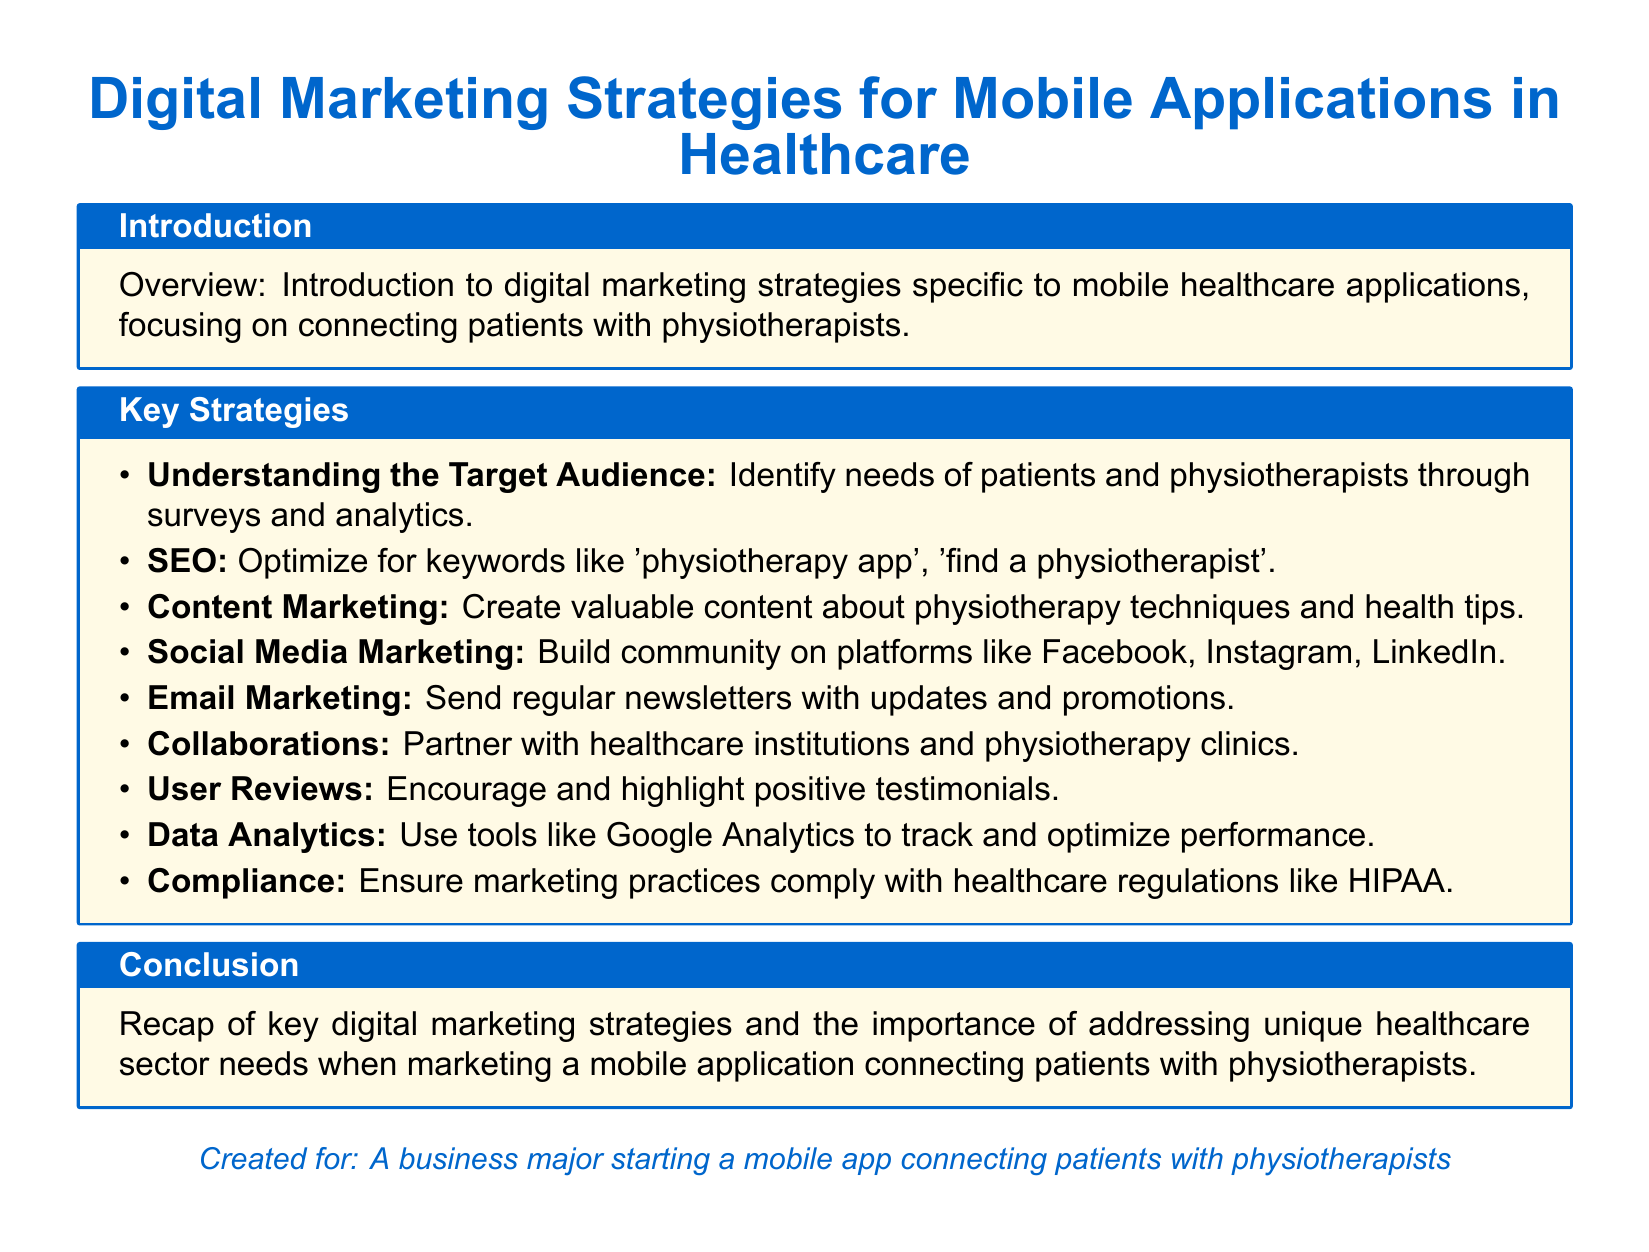What is the main focus of the document? The document provides an overview of digital marketing strategies for mobile healthcare applications, particularly in connecting patients with physiotherapists.
Answer: Connecting patients with physiotherapists How many key strategies are outlined in the document? The number of key strategies listed under the "Key Strategies" section can be counted.
Answer: Eight Which strategy involves using analytics tools? The strategy that involves tracking and optimizing performance using tools is mentioned explicitly.
Answer: Data Analytics What is a suggested platform for social media marketing? The document specifies a few platforms where community building is suggested; one of them is included here.
Answer: Facebook What should marketing practices comply with? The document highlights a specific regulation that marketing practices in healthcare should adhere to.
Answer: HIPAA What type of marketing involves sending newsletters? The document describes a specific kind of marketing focused on regular communication with users.
Answer: Email Marketing What is the purpose of content marketing as per this lesson plan? The lesson plan outlines that content marketing aims to create valuable information related to a specific field.
Answer: Create valuable content What audience needs should be understood according to the document? The document emphasizes understanding the needs of two specific groups related to the application.
Answer: Patients and physiotherapists 